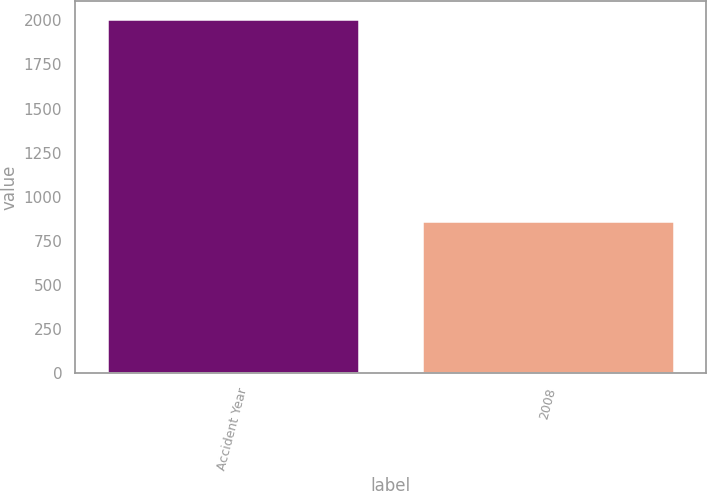Convert chart. <chart><loc_0><loc_0><loc_500><loc_500><bar_chart><fcel>Accident Year<fcel>2008<nl><fcel>2009<fcel>861<nl></chart> 